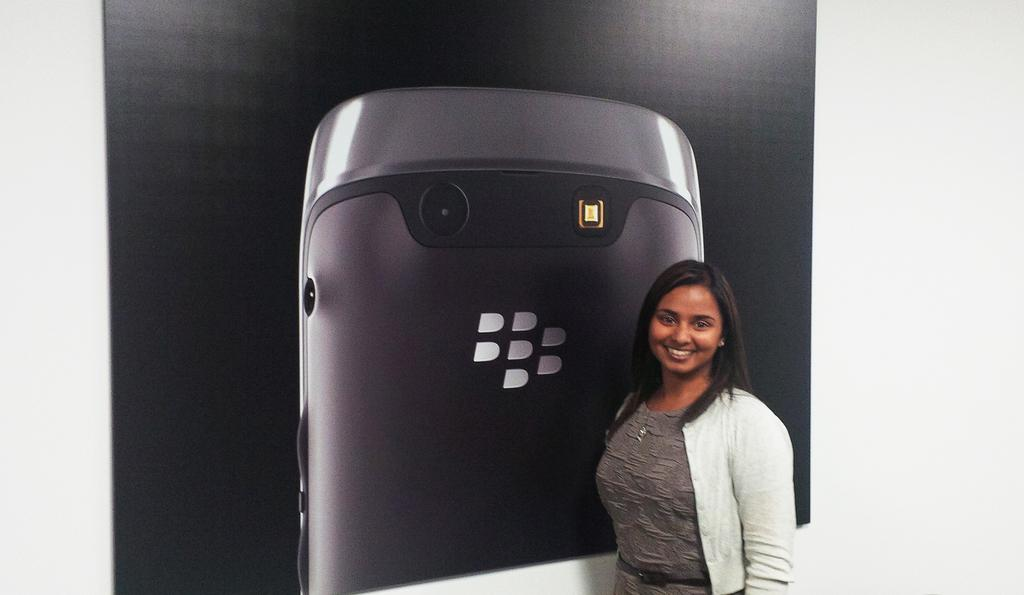Who or what is present in the image? There is a person in the image. What can be seen in the background of the image? There is a wall in the background of the image. What is on the wall? The wall has wallpaper on it. What is depicted on the wallpaper? There is a mobile phone depicted on the wallpaper. Is there any smoke coming from the mobile phone on the wallpaper? No, there is no smoke present in the image, and the mobile phone on the wallpaper is not depicted as emitting any smoke. 